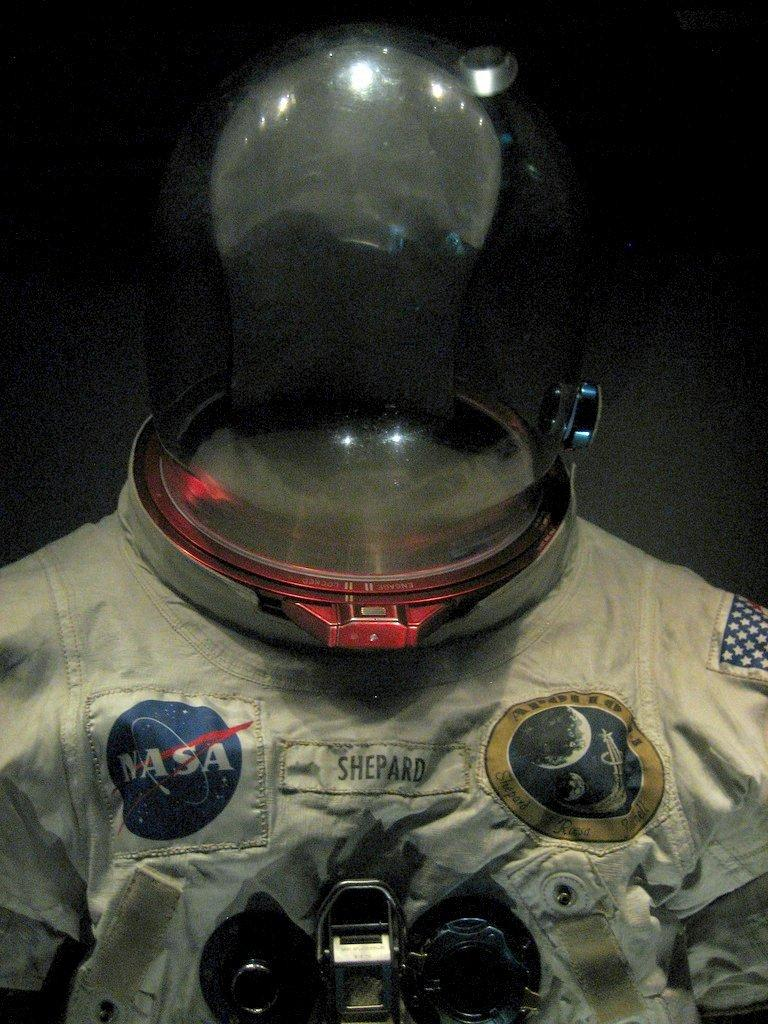What is the main subject of the image? The main subject of the image is an astronaut suit. What feature of the astronaut suit is mentioned in the image? There is text on the astronaut suit. What part of the astronaut suit is designed for protection? The astronaut suit has a helmet. How would you describe the overall appearance of the image? The background of the image is dark. How much debt is the astronaut suit carrying in the image? There is no information about debt in the image, as it features an astronaut suit with text and a helmet. What type of coin can be seen in the image? There is no coin, such as a quarter, present in the image. 